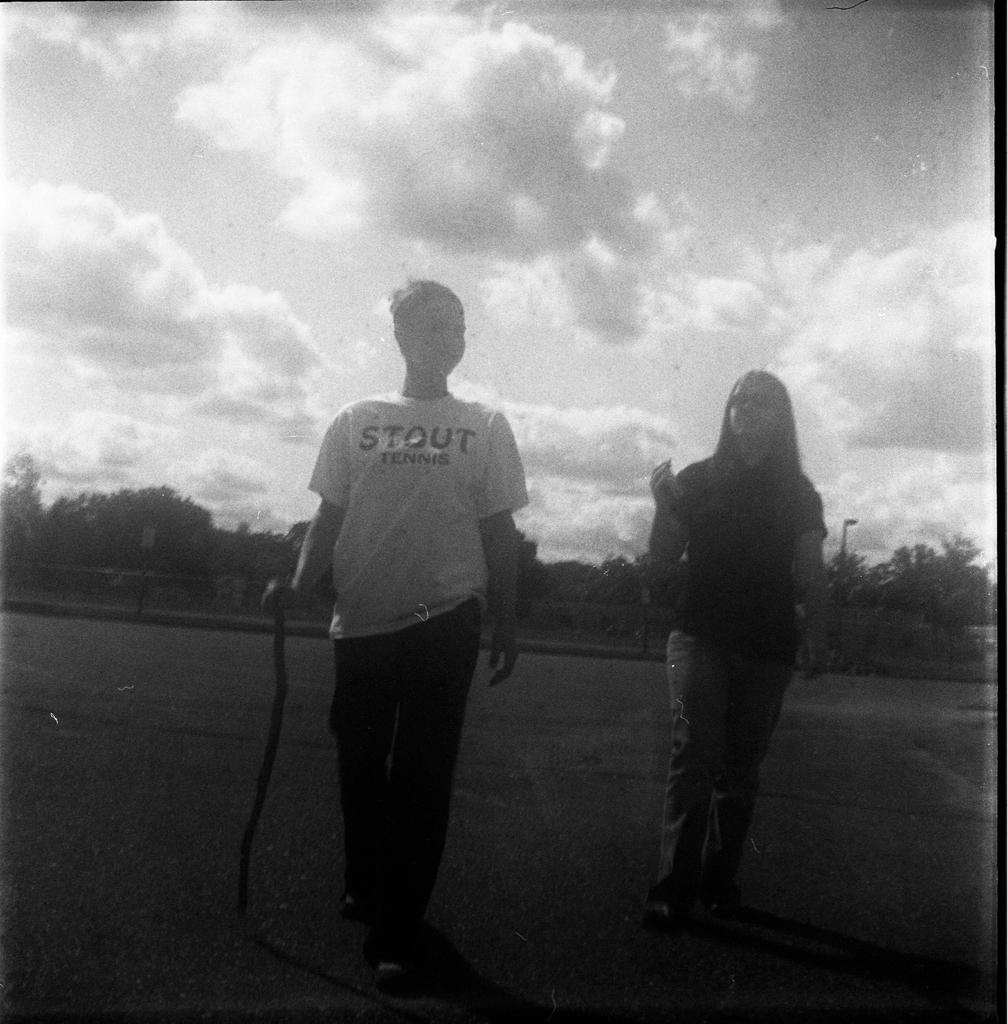What is the person holding in the image? The person is holding a stick in the image. What is the person doing with the stick? The person is walking while holding the stick. Can you describe the woman in the image? The woman is wearing goggles and walking in the image. What can be seen in the background of the image? The background of the image includes sky and trees. What is the tax rate for the person holding the stick in the image? There is no information about tax rates in the image, as it focuses on the person holding a stick and the woman wearing goggles. Is the crook visible in the image? There is no crook present in the image. 